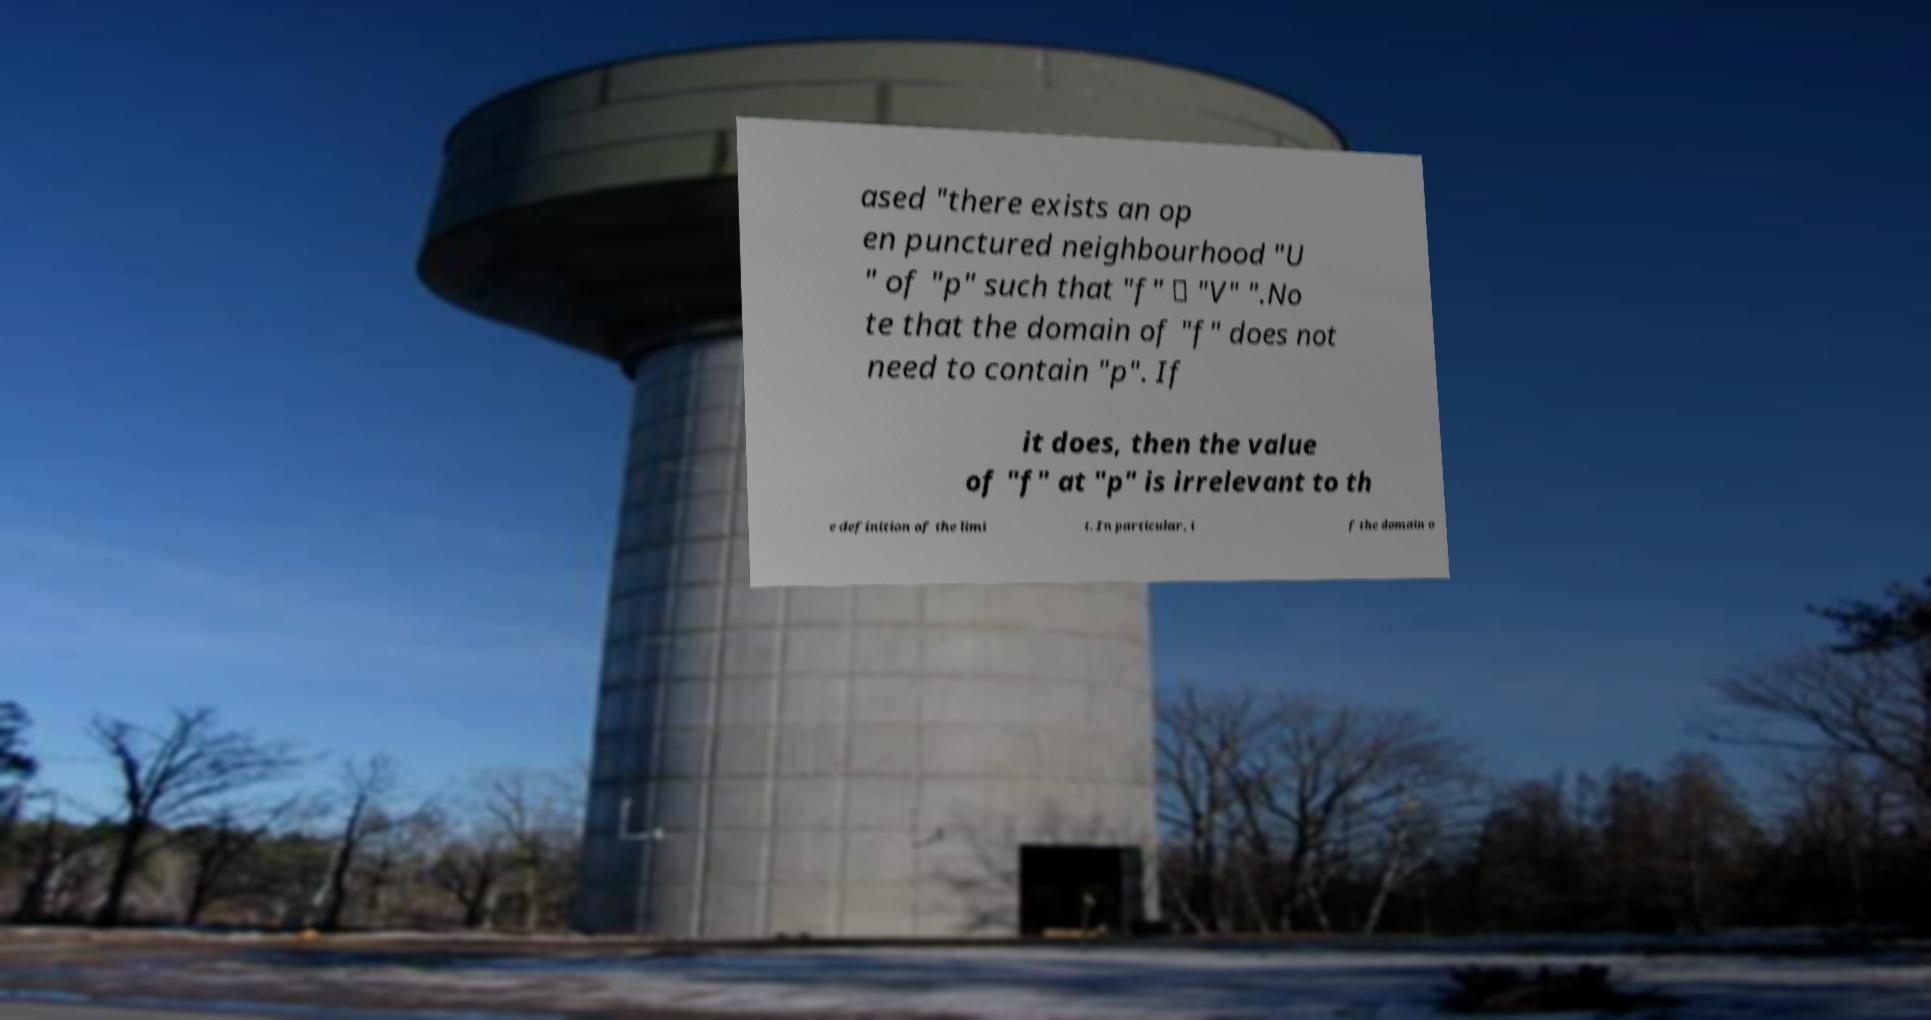Please identify and transcribe the text found in this image. ased "there exists an op en punctured neighbourhood "U " of "p" such that "f" ⊆ "V" ".No te that the domain of "f" does not need to contain "p". If it does, then the value of "f" at "p" is irrelevant to th e definition of the limi t. In particular, i f the domain o 